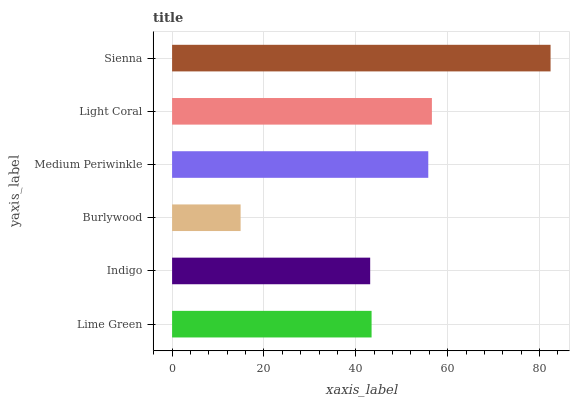Is Burlywood the minimum?
Answer yes or no. Yes. Is Sienna the maximum?
Answer yes or no. Yes. Is Indigo the minimum?
Answer yes or no. No. Is Indigo the maximum?
Answer yes or no. No. Is Lime Green greater than Indigo?
Answer yes or no. Yes. Is Indigo less than Lime Green?
Answer yes or no. Yes. Is Indigo greater than Lime Green?
Answer yes or no. No. Is Lime Green less than Indigo?
Answer yes or no. No. Is Medium Periwinkle the high median?
Answer yes or no. Yes. Is Lime Green the low median?
Answer yes or no. Yes. Is Burlywood the high median?
Answer yes or no. No. Is Light Coral the low median?
Answer yes or no. No. 